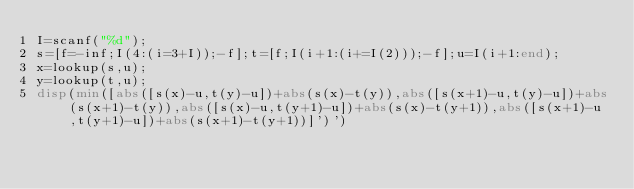<code> <loc_0><loc_0><loc_500><loc_500><_Octave_>I=scanf("%d");
s=[f=-inf;I(4:(i=3+I));-f];t=[f;I(i+1:(i+=I(2)));-f];u=I(i+1:end);
x=lookup(s,u);
y=lookup(t,u);
disp(min([abs([s(x)-u,t(y)-u])+abs(s(x)-t(y)),abs([s(x+1)-u,t(y)-u])+abs(s(x+1)-t(y)),abs([s(x)-u,t(y+1)-u])+abs(s(x)-t(y+1)),abs([s(x+1)-u,t(y+1)-u])+abs(s(x+1)-t(y+1))]')')</code> 